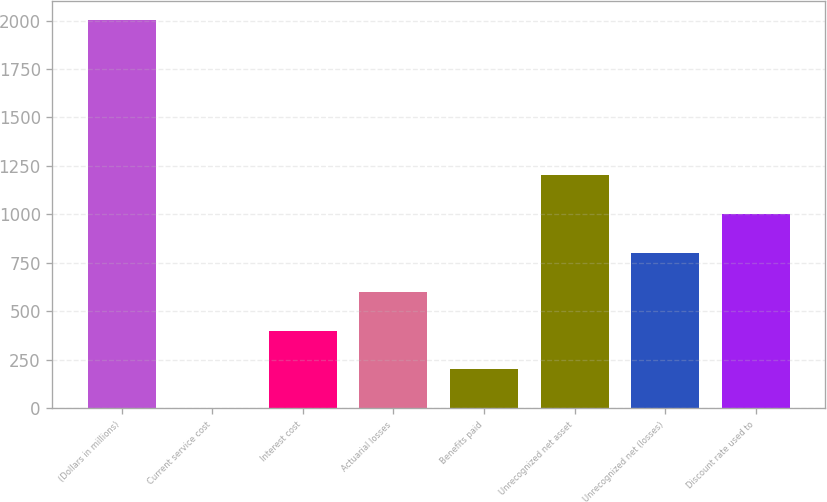<chart> <loc_0><loc_0><loc_500><loc_500><bar_chart><fcel>(Dollars in millions)<fcel>Current service cost<fcel>Interest cost<fcel>Actuarial losses<fcel>Benefits paid<fcel>Unrecognized net asset<fcel>Unrecognized net (losses)<fcel>Discount rate used to<nl><fcel>2001<fcel>1<fcel>401<fcel>601<fcel>201<fcel>1201<fcel>801<fcel>1001<nl></chart> 